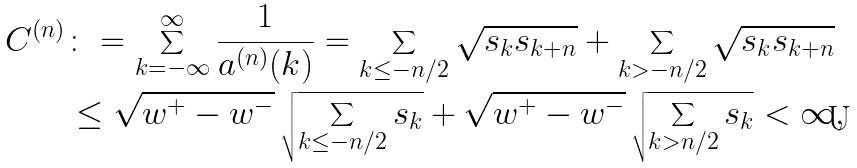Convert formula to latex. <formula><loc_0><loc_0><loc_500><loc_500>C ^ { ( n ) } & \colon = \sum _ { k = - \infty } ^ { \infty } \frac { 1 } { a ^ { ( n ) } ( k ) } = \sum _ { k \leq - n / 2 } \sqrt { s _ { k } s _ { k + n } } + \sum _ { k > - n / 2 } \sqrt { s _ { k } s _ { k + n } } \\ & \leq \sqrt { w ^ { + } - w ^ { - } } \, \sqrt { \sum _ { k \leq - n / 2 } s _ { k } } + \sqrt { w ^ { + } - w ^ { - } } \, \sqrt { \sum _ { k > n / 2 } s _ { k } } < \infty , \\</formula> 